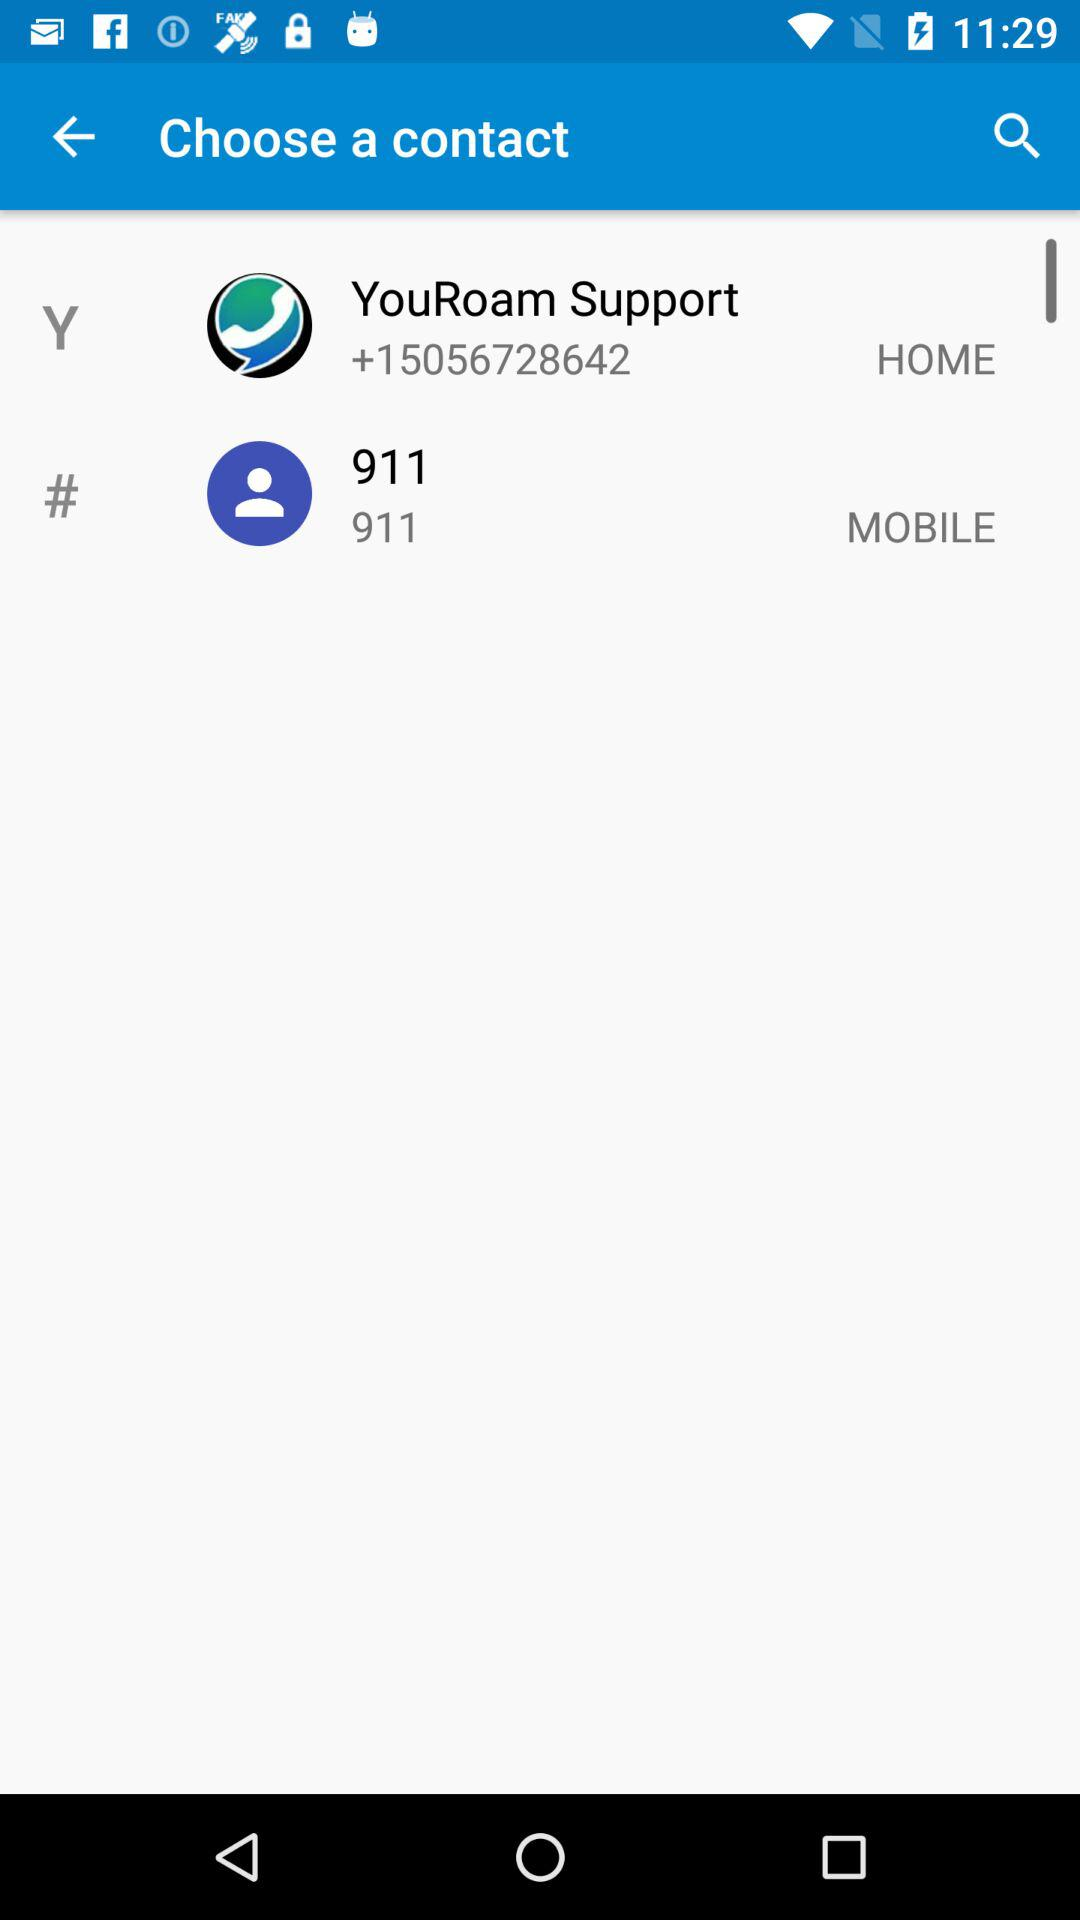What is the contact number for YouRoam Support? The contact number is "+15056728642". 